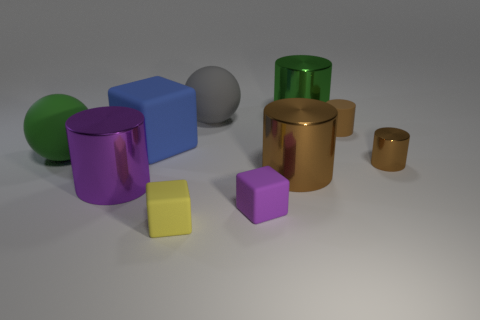Subtract all red cubes. How many brown cylinders are left? 3 Subtract 1 cubes. How many cubes are left? 2 Subtract all green cylinders. How many cylinders are left? 4 Subtract all large green shiny cylinders. How many cylinders are left? 4 Subtract all red cylinders. Subtract all blue cubes. How many cylinders are left? 5 Subtract all spheres. How many objects are left? 8 Add 7 yellow cubes. How many yellow cubes exist? 8 Subtract 1 blue blocks. How many objects are left? 9 Subtract all matte things. Subtract all small gray rubber balls. How many objects are left? 4 Add 6 large metal things. How many large metal things are left? 9 